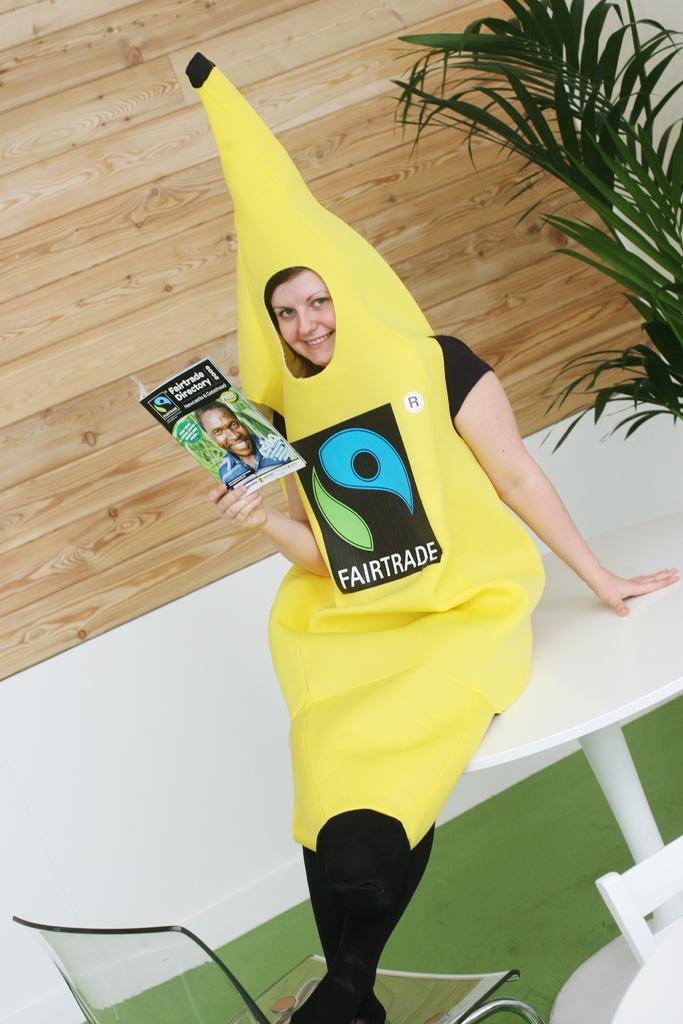Who is present in the image? There is a woman in the image. What is the woman sitting on? The woman is sitting on a white table. What is the woman holding in the image? The woman is holding a magazine. What can be seen on the right side of the image? There is a plant on the right side of the image. What type of furniture is visible at the bottom of the image? There is a chair visible at the bottom of the image. What type of steel structure can be seen in the image? There is no steel structure present in the image. How many cubs are playing with the ball in the image? There are no cubs or balls present in the image. 